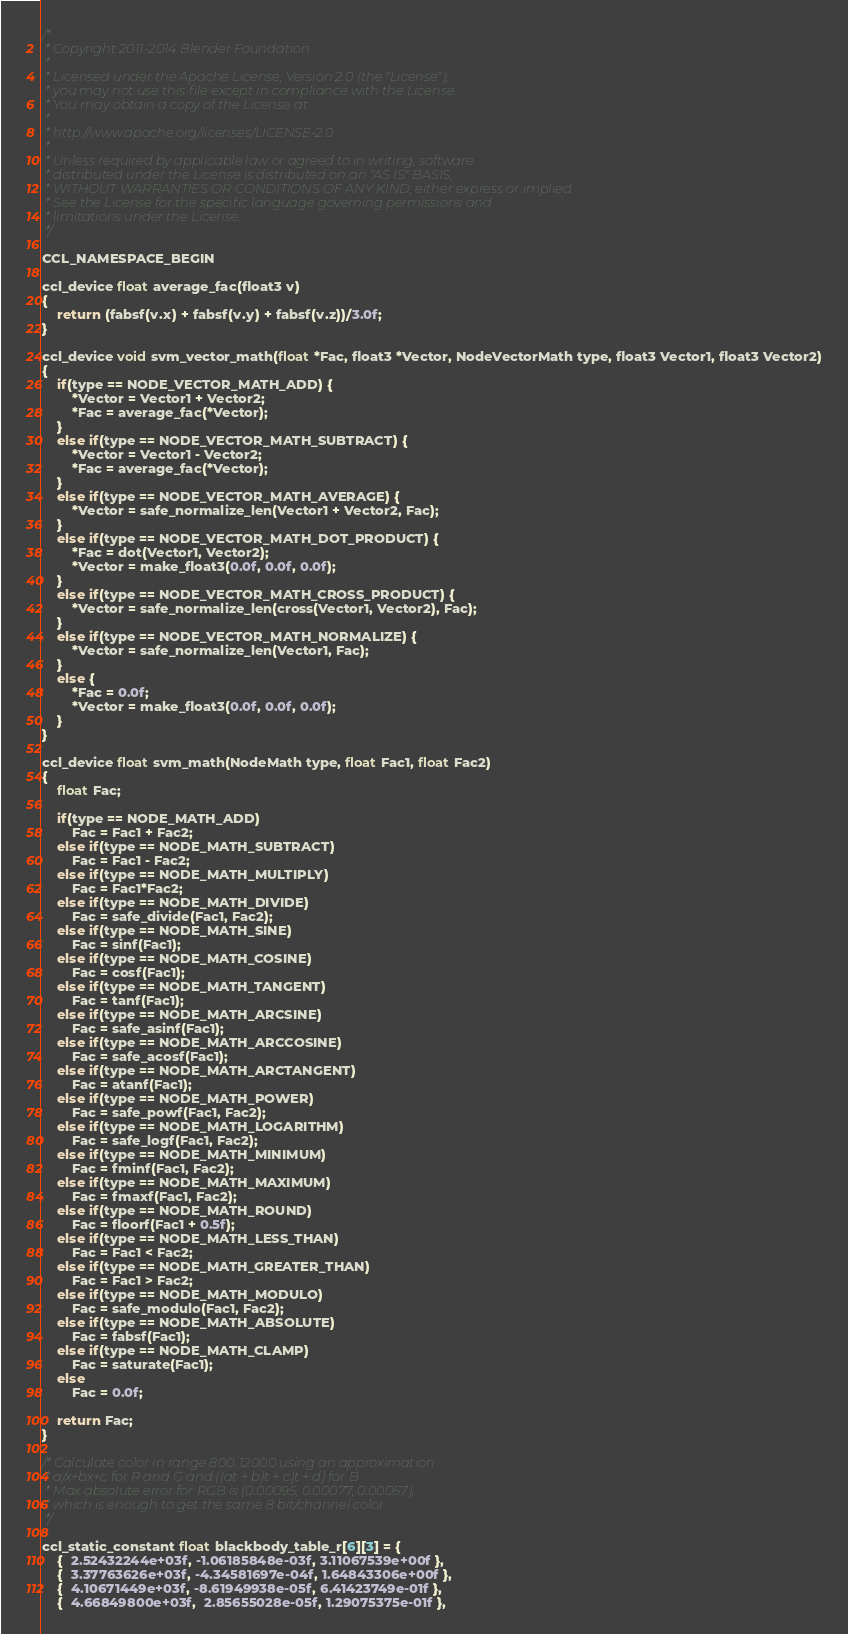Convert code to text. <code><loc_0><loc_0><loc_500><loc_500><_C_>/*
 * Copyright 2011-2014 Blender Foundation
 *
 * Licensed under the Apache License, Version 2.0 (the "License");
 * you may not use this file except in compliance with the License.
 * You may obtain a copy of the License at
 *
 * http://www.apache.org/licenses/LICENSE-2.0
 *
 * Unless required by applicable law or agreed to in writing, software
 * distributed under the License is distributed on an "AS IS" BASIS,
 * WITHOUT WARRANTIES OR CONDITIONS OF ANY KIND, either express or implied.
 * See the License for the specific language governing permissions and
 * limitations under the License.
 */

CCL_NAMESPACE_BEGIN

ccl_device float average_fac(float3 v)
{
	return (fabsf(v.x) + fabsf(v.y) + fabsf(v.z))/3.0f;
}

ccl_device void svm_vector_math(float *Fac, float3 *Vector, NodeVectorMath type, float3 Vector1, float3 Vector2)
{
	if(type == NODE_VECTOR_MATH_ADD) {
		*Vector = Vector1 + Vector2;
		*Fac = average_fac(*Vector);
	}
	else if(type == NODE_VECTOR_MATH_SUBTRACT) {
		*Vector = Vector1 - Vector2;
		*Fac = average_fac(*Vector);
	}
	else if(type == NODE_VECTOR_MATH_AVERAGE) {
		*Vector = safe_normalize_len(Vector1 + Vector2, Fac);
	}
	else if(type == NODE_VECTOR_MATH_DOT_PRODUCT) {
		*Fac = dot(Vector1, Vector2);
		*Vector = make_float3(0.0f, 0.0f, 0.0f);
	}
	else if(type == NODE_VECTOR_MATH_CROSS_PRODUCT) {
		*Vector = safe_normalize_len(cross(Vector1, Vector2), Fac);
	}
	else if(type == NODE_VECTOR_MATH_NORMALIZE) {
		*Vector = safe_normalize_len(Vector1, Fac);
	}
	else {
		*Fac = 0.0f;
		*Vector = make_float3(0.0f, 0.0f, 0.0f);
	}
}

ccl_device float svm_math(NodeMath type, float Fac1, float Fac2)
{
	float Fac;

	if(type == NODE_MATH_ADD)
		Fac = Fac1 + Fac2;
	else if(type == NODE_MATH_SUBTRACT)
		Fac = Fac1 - Fac2;
	else if(type == NODE_MATH_MULTIPLY)
		Fac = Fac1*Fac2;
	else if(type == NODE_MATH_DIVIDE)
		Fac = safe_divide(Fac1, Fac2);
	else if(type == NODE_MATH_SINE)
		Fac = sinf(Fac1);
	else if(type == NODE_MATH_COSINE)
		Fac = cosf(Fac1);
	else if(type == NODE_MATH_TANGENT)
		Fac = tanf(Fac1);
	else if(type == NODE_MATH_ARCSINE)
		Fac = safe_asinf(Fac1);
	else if(type == NODE_MATH_ARCCOSINE)
		Fac = safe_acosf(Fac1);
	else if(type == NODE_MATH_ARCTANGENT)
		Fac = atanf(Fac1);
	else if(type == NODE_MATH_POWER)
		Fac = safe_powf(Fac1, Fac2);
	else if(type == NODE_MATH_LOGARITHM)
		Fac = safe_logf(Fac1, Fac2);
	else if(type == NODE_MATH_MINIMUM)
		Fac = fminf(Fac1, Fac2);
	else if(type == NODE_MATH_MAXIMUM)
		Fac = fmaxf(Fac1, Fac2);
	else if(type == NODE_MATH_ROUND)
		Fac = floorf(Fac1 + 0.5f);
	else if(type == NODE_MATH_LESS_THAN)
		Fac = Fac1 < Fac2;
	else if(type == NODE_MATH_GREATER_THAN)
		Fac = Fac1 > Fac2;
	else if(type == NODE_MATH_MODULO)
		Fac = safe_modulo(Fac1, Fac2);
	else if(type == NODE_MATH_ABSOLUTE)
		Fac = fabsf(Fac1);
	else if(type == NODE_MATH_CLAMP)
		Fac = saturate(Fac1);
	else
		Fac = 0.0f;
	
	return Fac;
}

/* Calculate color in range 800..12000 using an approximation
 * a/x+bx+c for R and G and ((at + b)t + c)t + d) for B
 * Max absolute error for RGB is (0.00095, 0.00077, 0.00057),
 * which is enough to get the same 8 bit/channel color.
 */

ccl_static_constant float blackbody_table_r[6][3] = {
	{  2.52432244e+03f, -1.06185848e-03f, 3.11067539e+00f },
	{  3.37763626e+03f, -4.34581697e-04f, 1.64843306e+00f },
	{  4.10671449e+03f, -8.61949938e-05f, 6.41423749e-01f },
	{  4.66849800e+03f,  2.85655028e-05f, 1.29075375e-01f },</code> 